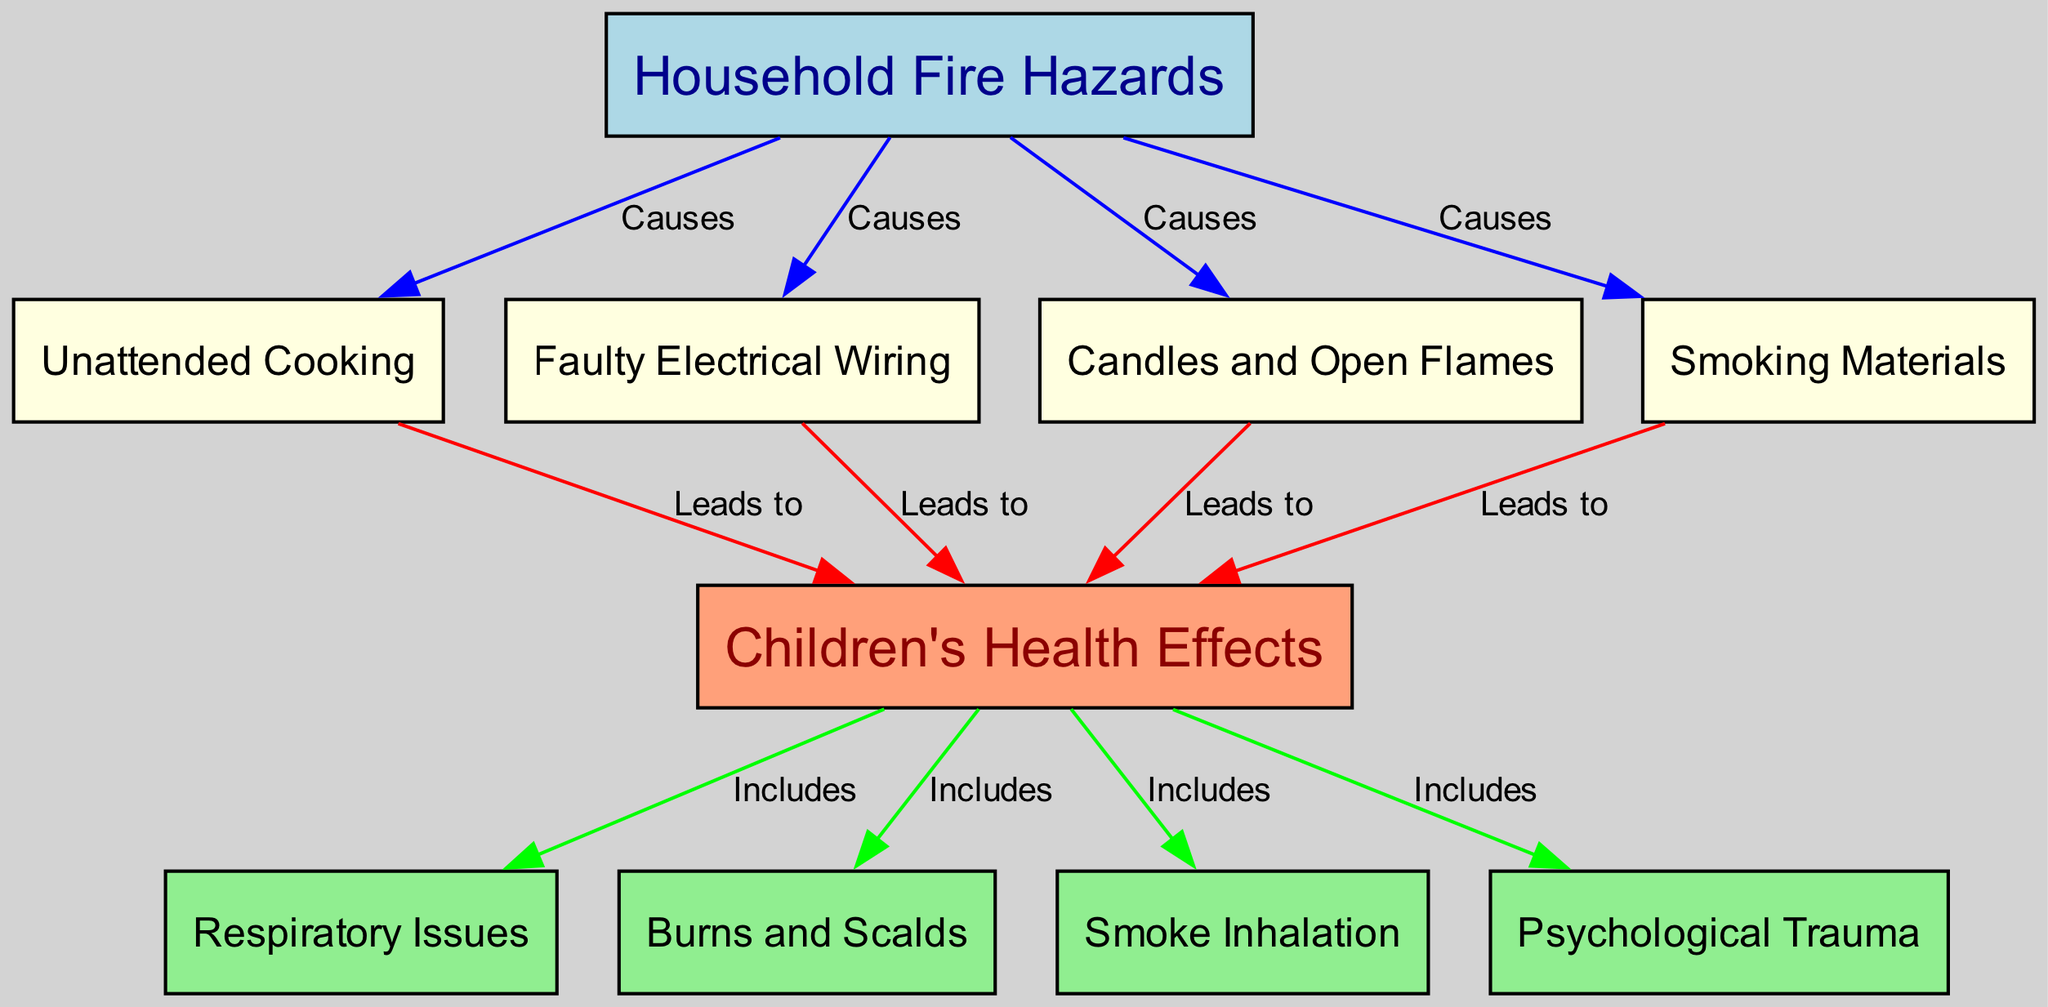What are the four common household fire hazards listed in the diagram? The diagram identifies four common household fire hazards: Unattended Cooking, Faulty Electrical Wiring, Candles and Open Flames, and Smoking Materials. These are directly labeled as nodes connected to "Household Fire Hazards."
Answer: Unattended Cooking, Faulty Electrical Wiring, Candles and Open Flames, Smoking Materials How many edges are present in the diagram? The diagram shows a total of eight edges connecting various nodes. These edges illustrate the causal relationships between household fire hazards and their effects on children's health.
Answer: Eight What effect does "Unattended Cooking" lead to in children's health according to the diagram? "Unattended Cooking" is connected to "Children's Health Effects" with an edge labeled "Leads to." This indicates that this hazard can result in health issues for children, as shown in the diagram.
Answer: Leads to Which specific health effect is associated with "Candles and Open Flames"? "Candles and Open Flames" connects to "Children's Health Effects," leading to various health issues. Among those listed, specific effects indicated include Burns and Scalds, Smoke Inhalation, and Psychological Trauma. Thus, the immediate effect is one of the listed issues.
Answer: Children’s Health Effects What health issues are included under "Children's Health Effects"? "Children's Health Effects" is shown to include several specific health issues: Respiratory Issues, Burns and Scalds, Smoke Inhalation, and Psychological Trauma. These are displayed as interconnected nodes pointing from "Children's Health Effects."
Answer: Respiratory Issues, Burns and Scalds, Smoke Inhalation, Psychological Trauma Which fire hazard is associated with "Smoking Materials"? "Smoking Materials" is connected to "Children's Health Effects" through an edge labeled "Leads to." This signifies that smoking materials pose a danger that can lead to health complications for children.
Answer: Leads to Children's Health Effects 